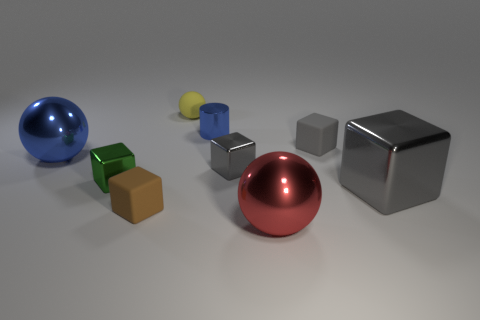Is the number of red balls that are behind the small rubber sphere greater than the number of tiny cubes that are left of the red shiny thing?
Your answer should be compact. No. Is the material of the big sphere to the left of the small yellow matte thing the same as the large sphere that is to the right of the green metallic block?
Keep it short and to the point. Yes. There is a yellow sphere; are there any gray cubes behind it?
Provide a succinct answer. No. How many blue objects are either matte objects or small metallic objects?
Make the answer very short. 1. Is the material of the tiny green block the same as the tiny gray thing behind the large blue ball?
Your answer should be compact. No. The yellow rubber thing that is the same shape as the large blue shiny object is what size?
Give a very brief answer. Small. What is the small yellow object made of?
Give a very brief answer. Rubber. What material is the blue thing on the left side of the block that is in front of the large thing right of the red metallic ball?
Ensure brevity in your answer.  Metal. There is a metallic ball on the right side of the blue shiny cylinder; is it the same size as the gray metallic thing in front of the tiny green metal cube?
Provide a succinct answer. Yes. What number of other objects are the same material as the big red object?
Offer a very short reply. 5. 